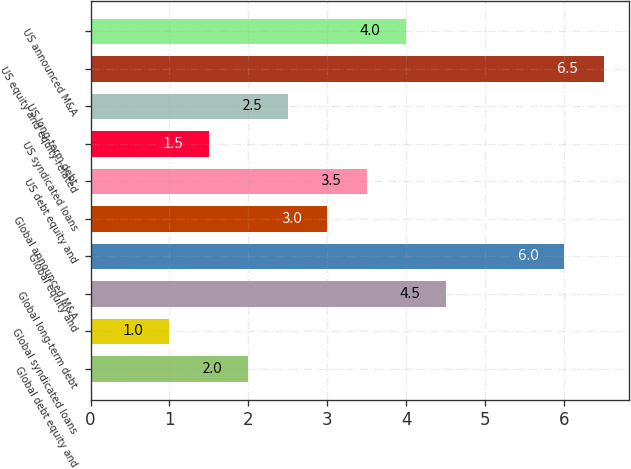<chart> <loc_0><loc_0><loc_500><loc_500><bar_chart><fcel>Global debt equity and<fcel>Global syndicated loans<fcel>Global long-term debt<fcel>Global equity and<fcel>Global announced M&A<fcel>US debt equity and<fcel>US syndicated loans<fcel>US long-term debt<fcel>US equity and equity-related<fcel>US announced M&A<nl><fcel>2<fcel>1<fcel>4.5<fcel>6<fcel>3<fcel>3.5<fcel>1.5<fcel>2.5<fcel>6.5<fcel>4<nl></chart> 